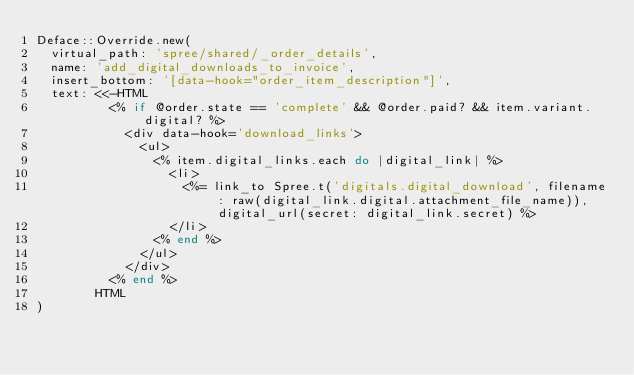<code> <loc_0><loc_0><loc_500><loc_500><_Ruby_>Deface::Override.new(
  virtual_path: 'spree/shared/_order_details',
  name: 'add_digital_downloads_to_invoice',
  insert_bottom: '[data-hook="order_item_description"]',
  text: <<-HTML
          <% if @order.state == 'complete' && @order.paid? && item.variant.digital? %>
            <div data-hook='download_links'>
              <ul>
                <% item.digital_links.each do |digital_link| %>
                  <li>
                    <%= link_to Spree.t('digitals.digital_download', filename: raw(digital_link.digital.attachment_file_name)), digital_url(secret: digital_link.secret) %>
                  </li>
                <% end %>
              </ul>
            </div>
          <% end %>
        HTML
)
</code> 